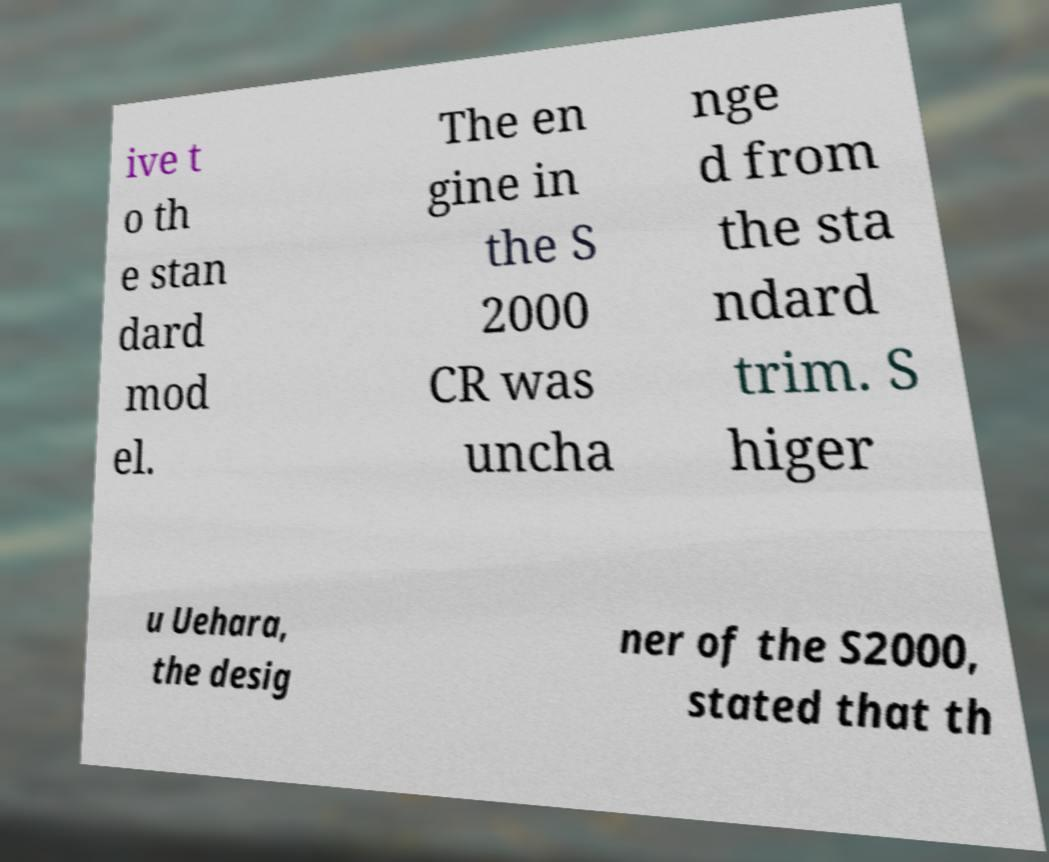There's text embedded in this image that I need extracted. Can you transcribe it verbatim? ive t o th e stan dard mod el. The en gine in the S 2000 CR was uncha nge d from the sta ndard trim. S higer u Uehara, the desig ner of the S2000, stated that th 